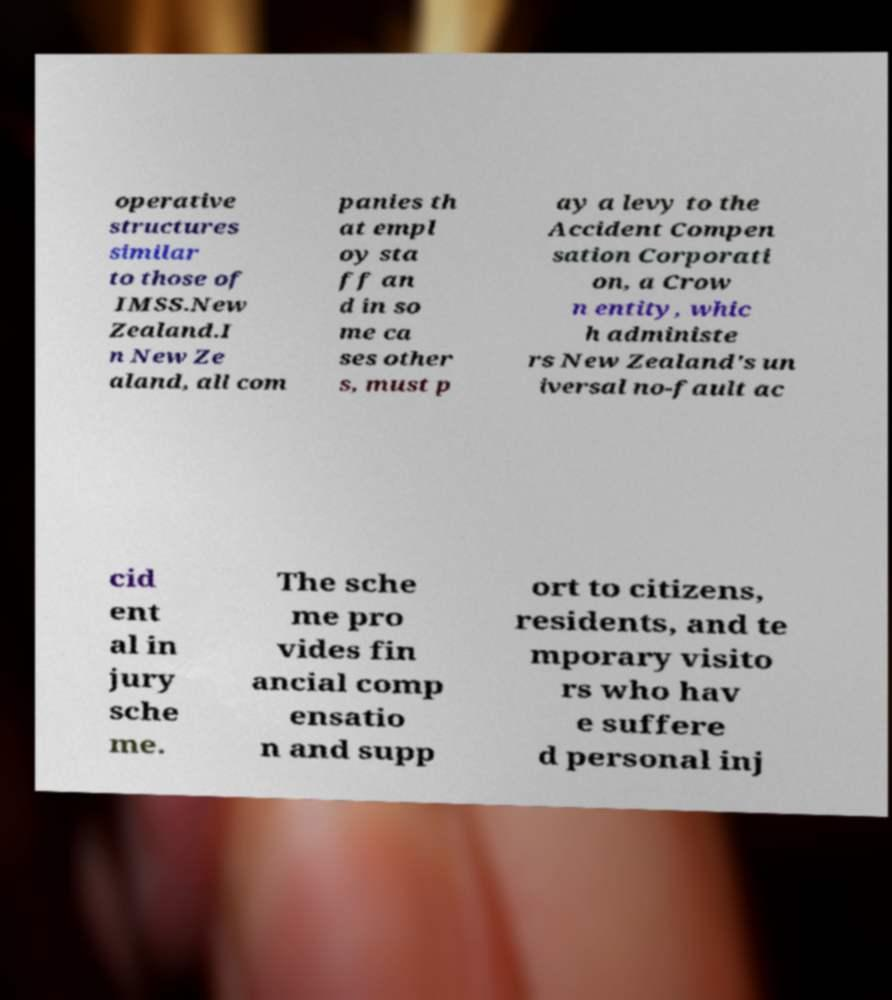There's text embedded in this image that I need extracted. Can you transcribe it verbatim? operative structures similar to those of IMSS.New Zealand.I n New Ze aland, all com panies th at empl oy sta ff an d in so me ca ses other s, must p ay a levy to the Accident Compen sation Corporati on, a Crow n entity, whic h administe rs New Zealand's un iversal no-fault ac cid ent al in jury sche me. The sche me pro vides fin ancial comp ensatio n and supp ort to citizens, residents, and te mporary visito rs who hav e suffere d personal inj 